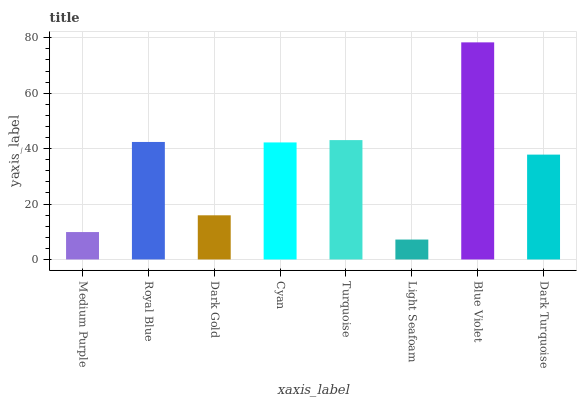Is Royal Blue the minimum?
Answer yes or no. No. Is Royal Blue the maximum?
Answer yes or no. No. Is Royal Blue greater than Medium Purple?
Answer yes or no. Yes. Is Medium Purple less than Royal Blue?
Answer yes or no. Yes. Is Medium Purple greater than Royal Blue?
Answer yes or no. No. Is Royal Blue less than Medium Purple?
Answer yes or no. No. Is Cyan the high median?
Answer yes or no. Yes. Is Dark Turquoise the low median?
Answer yes or no. Yes. Is Dark Gold the high median?
Answer yes or no. No. Is Royal Blue the low median?
Answer yes or no. No. 